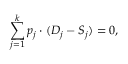Convert formula to latex. <formula><loc_0><loc_0><loc_500><loc_500>\sum _ { j = 1 } ^ { k } p _ { j } \cdot ( D _ { j } - S _ { j } ) = 0 ,</formula> 